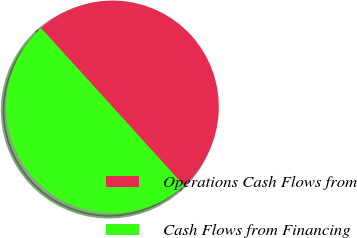Convert chart. <chart><loc_0><loc_0><loc_500><loc_500><pie_chart><fcel>Operations Cash Flows from<fcel>Cash Flows from Financing<nl><fcel>50.0%<fcel>50.0%<nl></chart> 